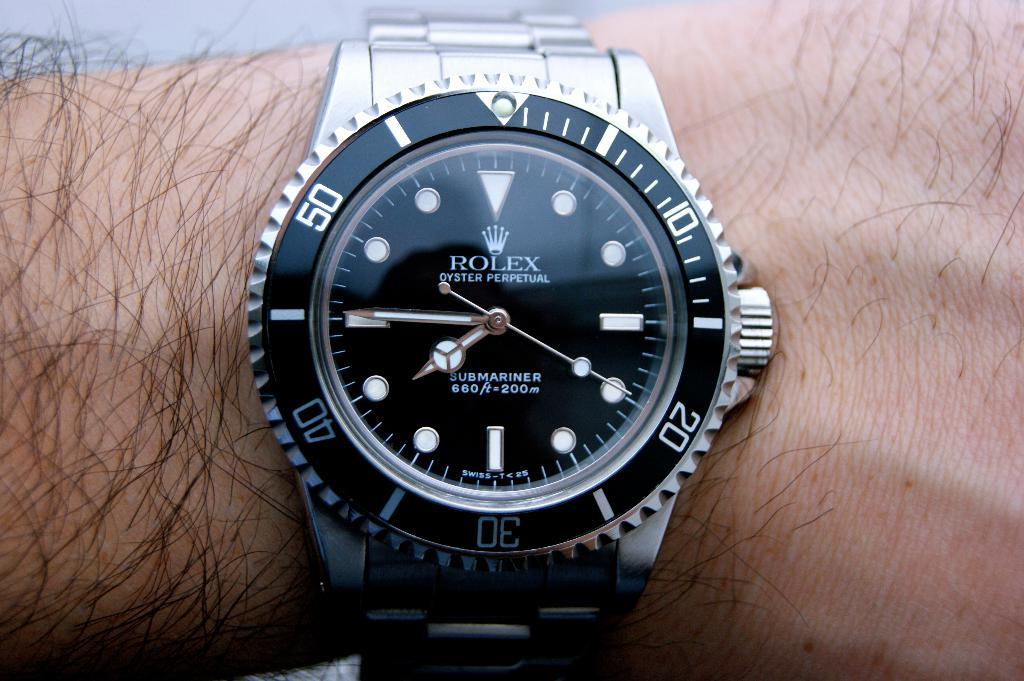Provide a one-sentence caption for the provided image. Face watch which has the wrod ROLEX on it. 